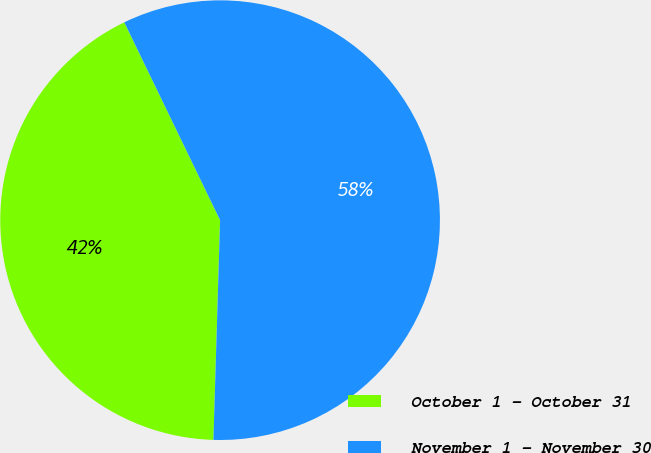Convert chart to OTSL. <chart><loc_0><loc_0><loc_500><loc_500><pie_chart><fcel>October 1 - October 31<fcel>November 1 - November 30<nl><fcel>42.34%<fcel>57.66%<nl></chart> 